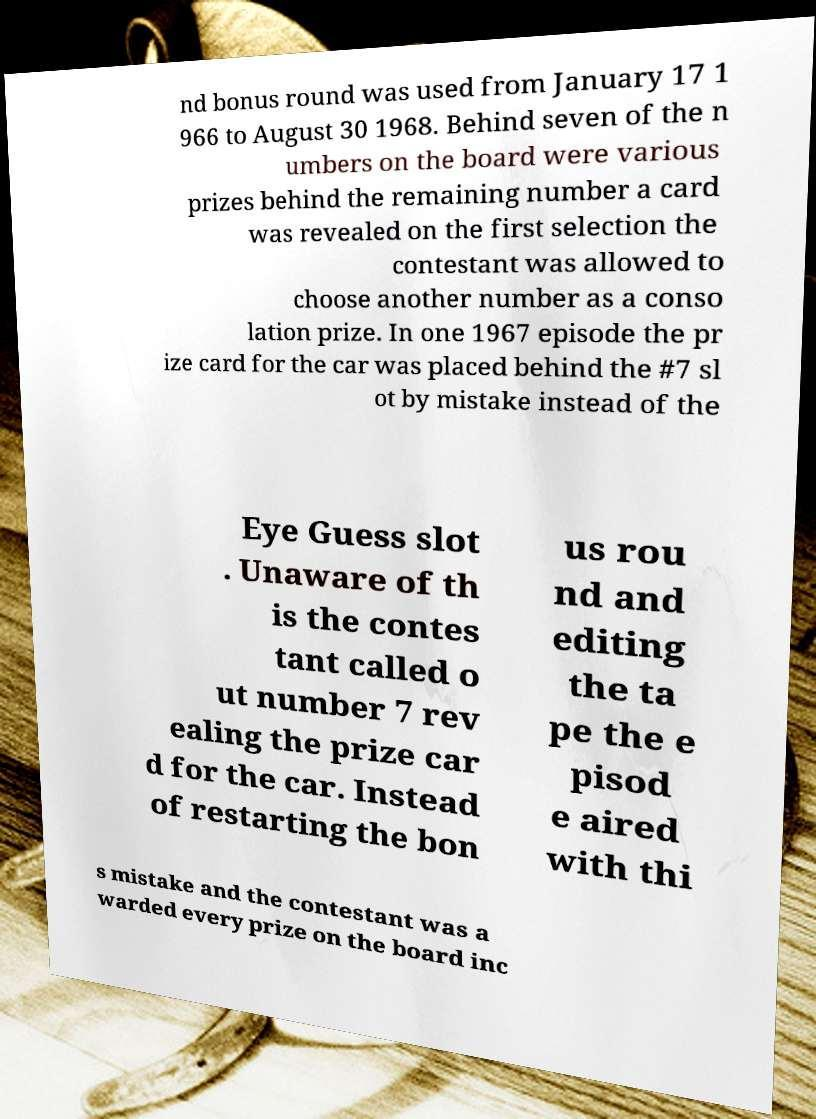Please read and relay the text visible in this image. What does it say? nd bonus round was used from January 17 1 966 to August 30 1968. Behind seven of the n umbers on the board were various prizes behind the remaining number a card was revealed on the first selection the contestant was allowed to choose another number as a conso lation prize. In one 1967 episode the pr ize card for the car was placed behind the #7 sl ot by mistake instead of the Eye Guess slot . Unaware of th is the contes tant called o ut number 7 rev ealing the prize car d for the car. Instead of restarting the bon us rou nd and editing the ta pe the e pisod e aired with thi s mistake and the contestant was a warded every prize on the board inc 